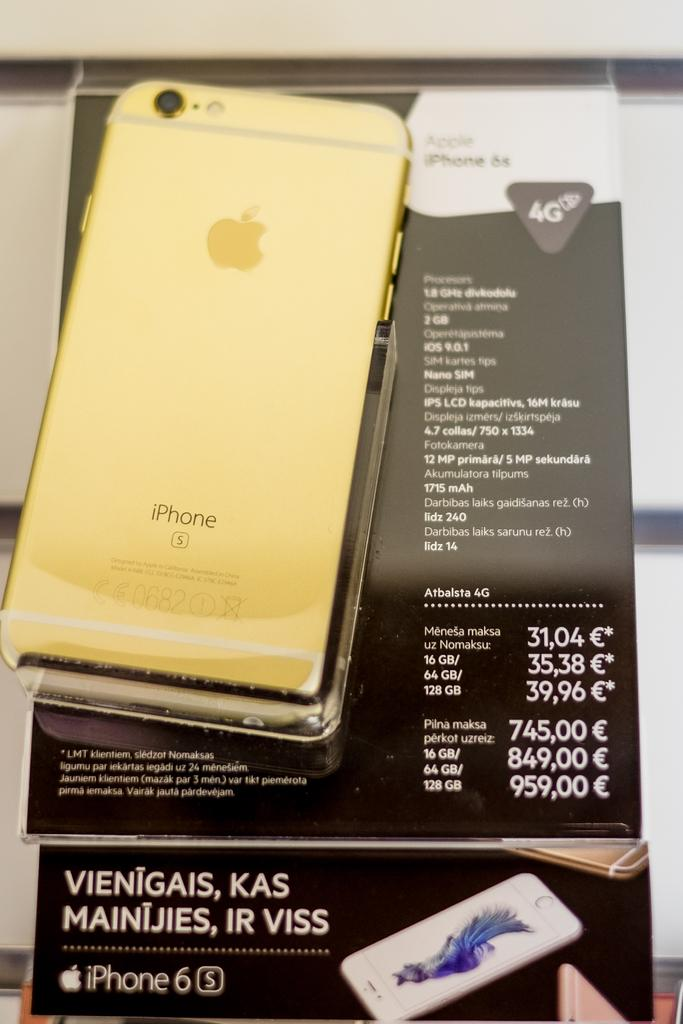What object is placed on a paper in the image? There is a phone on a paper in the image. What can be found on the paper with the phone? The paper has text on it. Are there any other papers with text in the image? Yes, there is another paper with text in the image. What is depicted on the second paper with text? The second paper has images of a phone. What type of cherries are being used to decorate the phone in the image? There are no cherries present in the image; the second paper with text has images of a phone, but no cherries are depicted. 